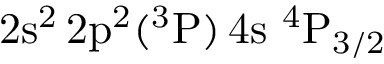Convert formula to latex. <formula><loc_0><loc_0><loc_500><loc_500>2 s ^ { 2 } \, 2 p ^ { 2 } ( ^ { 3 } P ) \, 4 s ^ { 4 } P _ { 3 / 2 }</formula> 